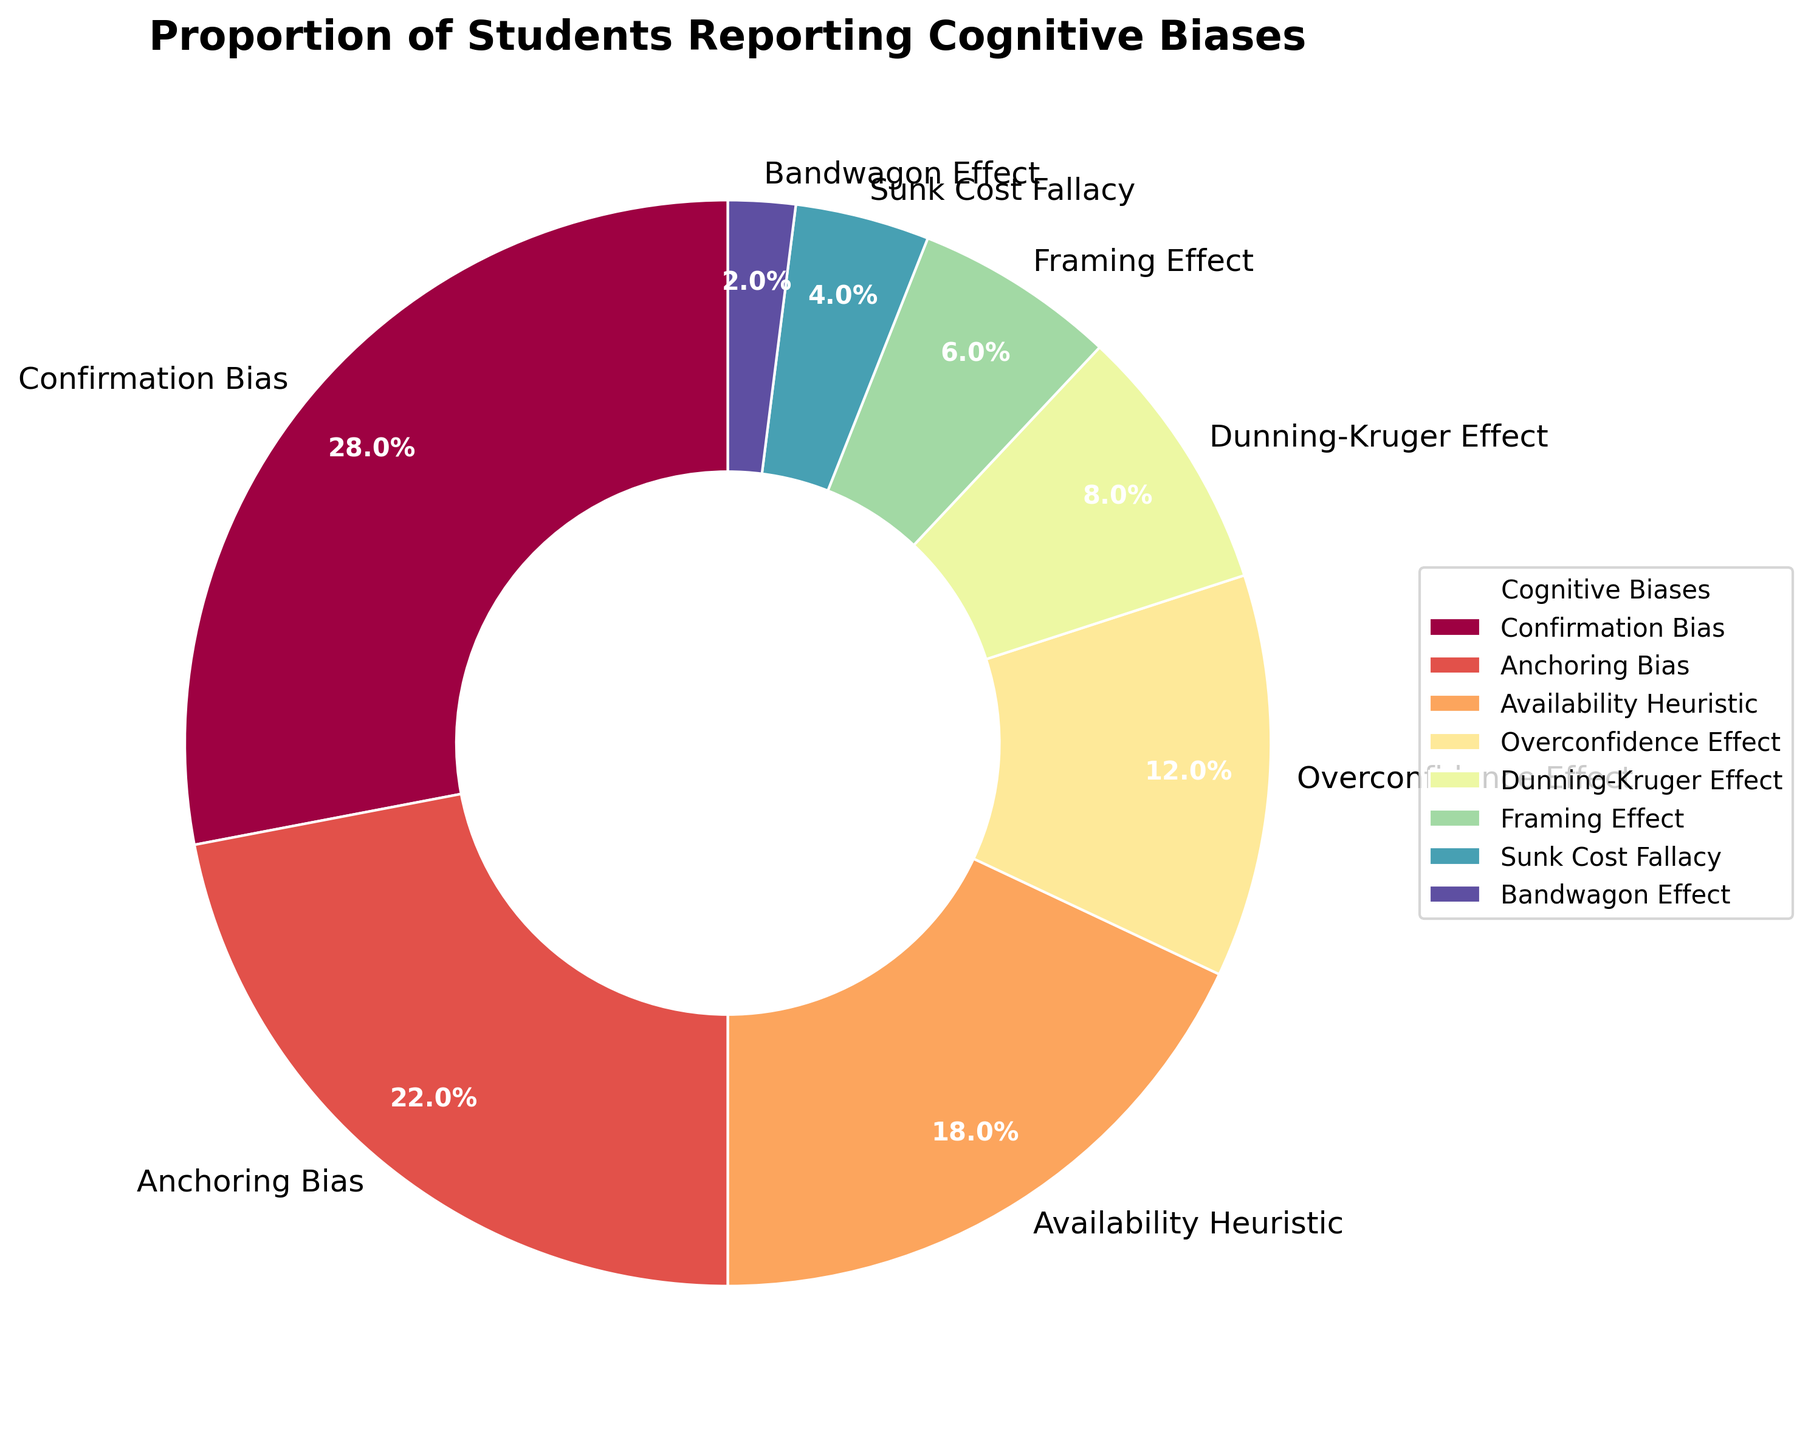Which cognitive bias is reported by the highest percentage of students? The pie chart shows the proportions of students reporting various cognitive biases. The largest segment of the pie is labeled "Confirmation Bias" with a percentage of 28%.
Answer: Confirmation Bias What is the combined percentage of students reporting Overconfidence Effect and Dunning-Kruger Effect? To find the combined percentage, add the percentage of students who reported Overconfidence Effect (12%) and Dunning-Kruger Effect (8%). The sum is 12% + 8% = 20%.
Answer: 20 Which cognitive bias is reported by the smallest percentage of students? The pie chart shows the smallest segment is labeled "Bandwagon Effect" with a percentage of 2%.
Answer: Bandwagon Effect How much greater is the percentage of students reporting Anchoring Bias compared to Availability Heuristic? To solve this, subtract the percentage of Availability Heuristic (18%) from the percentage of Anchoring Bias (22%). The difference is 22% - 18% = 4%.
Answer: 4 Are there more students reporting Confirmation Bias or all the biases with percentages of less than 10% combined? Sum the percentages of Dunning-Kruger Effect (8%), Framing Effect (6%), Sunk Cost Fallacy (4%), and Bandwagon Effect (2%): 8% + 6% + 4% + 2% = 20%. Confirmation Bias alone is 28%, which is greater than the sum of the other biases combined.
Answer: Yes What percentage of students report biases related to heuristic processing (Anchoring Bias, Availability Heuristic)? Sum the percentages of Anchoring Bias (22%) and Availability Heuristic (18%): 22% + 18% = 40%.
Answer: 40 Which two biases together make up the most significant percentage of students reporting cognitive biases? The two highest percentages in the pie chart are Confirmation Bias (28%) and Anchoring Bias (22%). Their combined percentage is 28% + 22% = 50%.
Answer: Confirmation Bias and Anchoring Bias What is the difference in percentage between the highest and lowest reported cognitive biases? The highest percentage is for Confirmation Bias (28%), and the lowest is for Bandwagon Effect (2%). The difference is 28% - 2% = 26%.
Answer: 26 